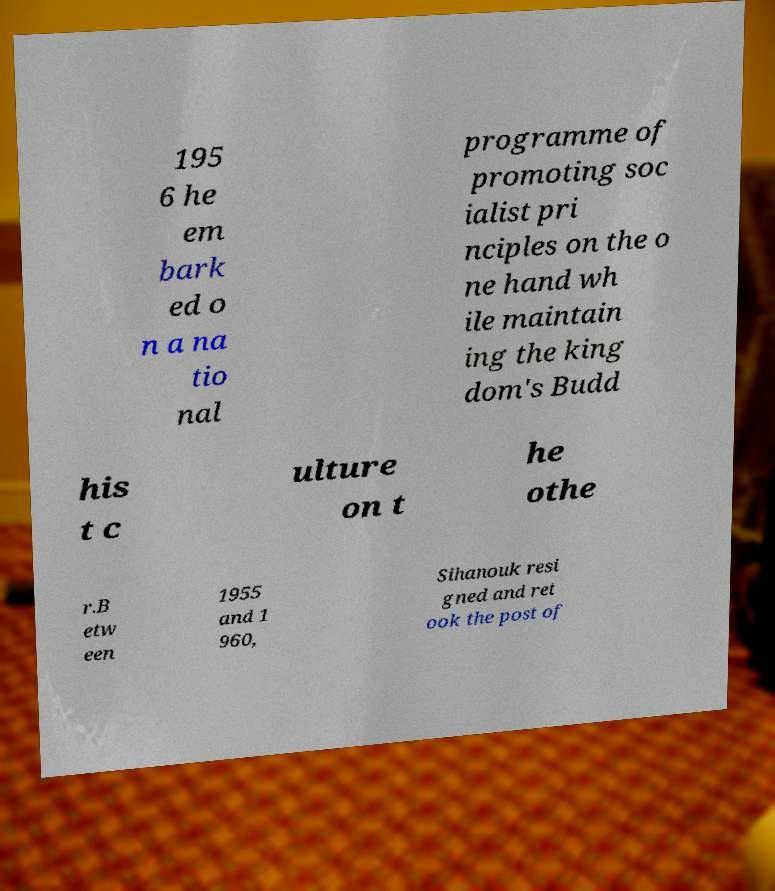What messages or text are displayed in this image? I need them in a readable, typed format. 195 6 he em bark ed o n a na tio nal programme of promoting soc ialist pri nciples on the o ne hand wh ile maintain ing the king dom's Budd his t c ulture on t he othe r.B etw een 1955 and 1 960, Sihanouk resi gned and ret ook the post of 